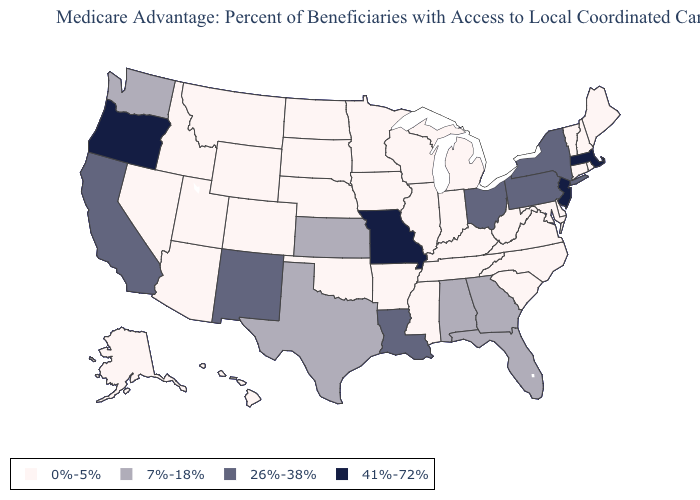Does Missouri have a higher value than Oregon?
Concise answer only. No. What is the highest value in the MidWest ?
Keep it brief. 41%-72%. Does Oregon have the highest value in the West?
Keep it brief. Yes. Does South Dakota have the lowest value in the MidWest?
Concise answer only. Yes. What is the value of South Dakota?
Short answer required. 0%-5%. Does Alabama have the same value as Alaska?
Write a very short answer. No. Name the states that have a value in the range 41%-72%?
Concise answer only. Massachusetts, Missouri, New Jersey, Oregon. Name the states that have a value in the range 26%-38%?
Be succinct. California, Louisiana, New Mexico, New York, Ohio, Pennsylvania. Does the map have missing data?
Be succinct. No. Name the states that have a value in the range 26%-38%?
Be succinct. California, Louisiana, New Mexico, New York, Ohio, Pennsylvania. What is the highest value in the West ?
Write a very short answer. 41%-72%. Among the states that border Wyoming , which have the highest value?
Answer briefly. Colorado, Idaho, Montana, Nebraska, South Dakota, Utah. Is the legend a continuous bar?
Concise answer only. No. What is the lowest value in states that border Tennessee?
Write a very short answer. 0%-5%. Does Iowa have the lowest value in the USA?
Be succinct. Yes. 